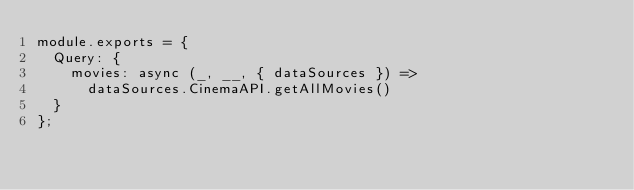Convert code to text. <code><loc_0><loc_0><loc_500><loc_500><_JavaScript_>module.exports = {
  Query: {
    movies: async (_, __, { dataSources }) =>
      dataSources.CinemaAPI.getAllMovies()
  }
};
</code> 